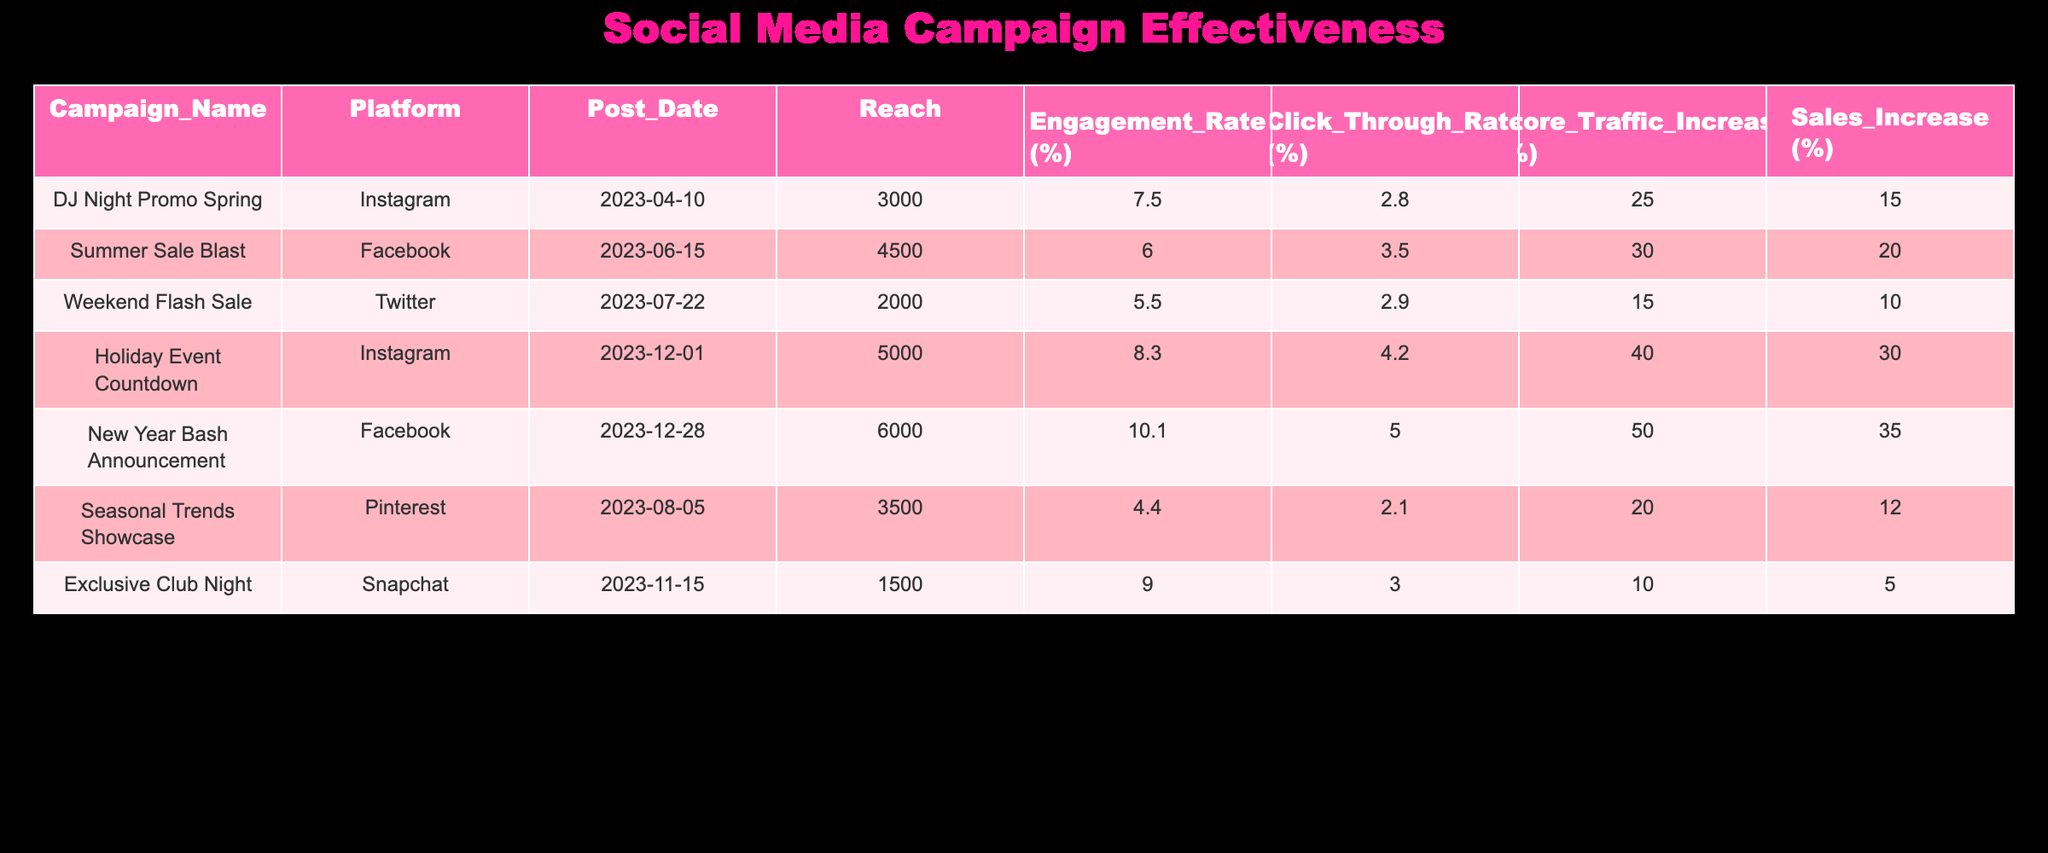What is the maximum reach of any campaign? The reach for each campaign is given in the table, and we can compare the values. The campaign with the highest reach is "New Year Bash Announcement," which has a reach of 6000.
Answer: 6000 Which social media platform had the highest engagement rate? By examining the engagement rates in the table, we find that the "New Year Bash Announcement" campaign on Facebook has the highest engagement rate at 10.1%.
Answer: 10.1% What was the average increase in store traffic due to the campaigns? To find the average increase in store traffic, we add up all the traffic increases: 25 + 30 + 15 + 40 + 50 + 20 + 10 = 190. There are 7 campaigns, so we divide 190 by 7, which gives us approximately 27.14.
Answer: 27.14 Did the "Holiday Event Countdown" campaign lead to a greater increase in sales than the "Weekend Flash Sale"? The sales increase for the "Holiday Event Countdown" is 30%, while the increase for the "Weekend Flash Sale" is 10%. Since 30% is greater than 10%, the answer is yes.
Answer: Yes How much higher is the Click Through Rate for the "Summer Sale Blast" compared to the "Exclusive Club Night"? For "Summer Sale Blast," the Click Through Rate (CTR) is 3.5%, and for "Exclusive Club Night," it is 3.0%. The difference in CTR is 3.5% - 3.0% = 0.5%.
Answer: 0.5% What is the total sales increase from all campaigns? We can calculate the total sales increase by summing the sales increases from all campaigns: 15 + 20 + 10 + 30 + 35 + 12 + 5 = 127.
Answer: 127 Is the average engagement rate of the Instagram campaigns higher than that of Facebook campaigns? The Instagram campaigns have engagement rates of 7.5% and 8.3%, giving an average of (7.5 + 8.3)/2 = 7.9%. The Facebook campaigns have engagement rates of 6.0% and 10.1%, giving an average of (6.0 + 10.1)/2 = 8.05%. Since 7.9% is less than 8.05%, the answer is no.
Answer: No Which campaign had the least impact on store traffic? The "Exclusive Club Night" campaign showed the least impact on store traffic, with an increase of only 10%.
Answer: 10% 